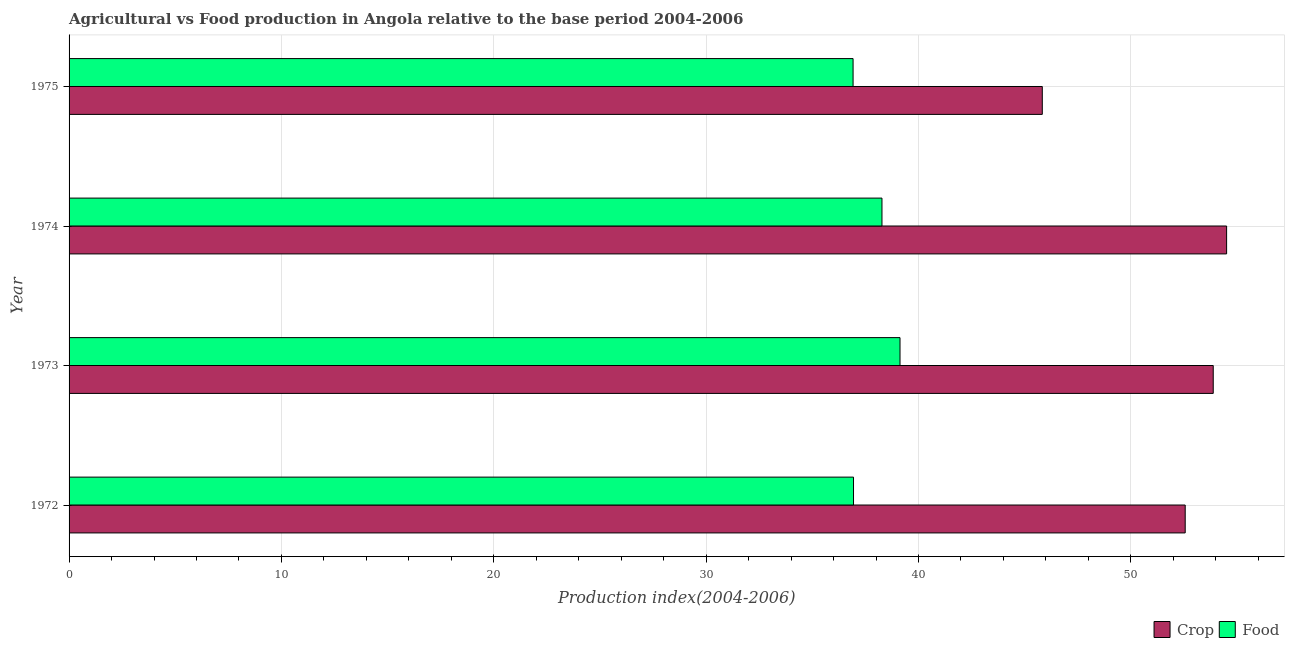What is the label of the 1st group of bars from the top?
Your answer should be very brief. 1975. What is the food production index in 1974?
Provide a short and direct response. 38.28. Across all years, what is the maximum crop production index?
Offer a terse response. 54.51. Across all years, what is the minimum food production index?
Offer a terse response. 36.92. In which year was the crop production index maximum?
Make the answer very short. 1974. In which year was the food production index minimum?
Give a very brief answer. 1975. What is the total crop production index in the graph?
Your answer should be compact. 206.78. What is the difference between the food production index in 1972 and that in 1973?
Your answer should be very brief. -2.19. What is the difference between the crop production index in 1972 and the food production index in 1974?
Your response must be concise. 14.28. What is the average food production index per year?
Keep it short and to the point. 37.82. In the year 1974, what is the difference between the crop production index and food production index?
Keep it short and to the point. 16.23. What is the ratio of the food production index in 1973 to that in 1975?
Give a very brief answer. 1.06. Is the crop production index in 1972 less than that in 1975?
Provide a short and direct response. No. What is the difference between the highest and the lowest crop production index?
Give a very brief answer. 8.68. Is the sum of the food production index in 1972 and 1974 greater than the maximum crop production index across all years?
Your answer should be compact. Yes. What does the 2nd bar from the top in 1973 represents?
Offer a very short reply. Crop. What does the 2nd bar from the bottom in 1973 represents?
Give a very brief answer. Food. How many bars are there?
Provide a short and direct response. 8. How many years are there in the graph?
Offer a very short reply. 4. What is the difference between two consecutive major ticks on the X-axis?
Provide a short and direct response. 10. Are the values on the major ticks of X-axis written in scientific E-notation?
Give a very brief answer. No. Where does the legend appear in the graph?
Your answer should be very brief. Bottom right. How many legend labels are there?
Provide a succinct answer. 2. How are the legend labels stacked?
Make the answer very short. Horizontal. What is the title of the graph?
Offer a very short reply. Agricultural vs Food production in Angola relative to the base period 2004-2006. Does "Methane" appear as one of the legend labels in the graph?
Your answer should be compact. No. What is the label or title of the X-axis?
Your answer should be compact. Production index(2004-2006). What is the Production index(2004-2006) in Crop in 1972?
Your answer should be compact. 52.56. What is the Production index(2004-2006) of Food in 1972?
Your answer should be very brief. 36.94. What is the Production index(2004-2006) of Crop in 1973?
Offer a very short reply. 53.88. What is the Production index(2004-2006) of Food in 1973?
Make the answer very short. 39.13. What is the Production index(2004-2006) in Crop in 1974?
Keep it short and to the point. 54.51. What is the Production index(2004-2006) in Food in 1974?
Ensure brevity in your answer.  38.28. What is the Production index(2004-2006) in Crop in 1975?
Provide a short and direct response. 45.83. What is the Production index(2004-2006) of Food in 1975?
Make the answer very short. 36.92. Across all years, what is the maximum Production index(2004-2006) in Crop?
Ensure brevity in your answer.  54.51. Across all years, what is the maximum Production index(2004-2006) in Food?
Your answer should be compact. 39.13. Across all years, what is the minimum Production index(2004-2006) of Crop?
Your answer should be compact. 45.83. Across all years, what is the minimum Production index(2004-2006) of Food?
Keep it short and to the point. 36.92. What is the total Production index(2004-2006) in Crop in the graph?
Your answer should be compact. 206.78. What is the total Production index(2004-2006) in Food in the graph?
Make the answer very short. 151.27. What is the difference between the Production index(2004-2006) in Crop in 1972 and that in 1973?
Keep it short and to the point. -1.32. What is the difference between the Production index(2004-2006) of Food in 1972 and that in 1973?
Your response must be concise. -2.19. What is the difference between the Production index(2004-2006) in Crop in 1972 and that in 1974?
Give a very brief answer. -1.95. What is the difference between the Production index(2004-2006) in Food in 1972 and that in 1974?
Your response must be concise. -1.34. What is the difference between the Production index(2004-2006) in Crop in 1972 and that in 1975?
Make the answer very short. 6.73. What is the difference between the Production index(2004-2006) of Crop in 1973 and that in 1974?
Your answer should be very brief. -0.63. What is the difference between the Production index(2004-2006) of Food in 1973 and that in 1974?
Make the answer very short. 0.85. What is the difference between the Production index(2004-2006) of Crop in 1973 and that in 1975?
Offer a terse response. 8.05. What is the difference between the Production index(2004-2006) of Food in 1973 and that in 1975?
Your answer should be very brief. 2.21. What is the difference between the Production index(2004-2006) in Crop in 1974 and that in 1975?
Make the answer very short. 8.68. What is the difference between the Production index(2004-2006) in Food in 1974 and that in 1975?
Give a very brief answer. 1.36. What is the difference between the Production index(2004-2006) in Crop in 1972 and the Production index(2004-2006) in Food in 1973?
Your answer should be very brief. 13.43. What is the difference between the Production index(2004-2006) of Crop in 1972 and the Production index(2004-2006) of Food in 1974?
Offer a very short reply. 14.28. What is the difference between the Production index(2004-2006) of Crop in 1972 and the Production index(2004-2006) of Food in 1975?
Your answer should be compact. 15.64. What is the difference between the Production index(2004-2006) of Crop in 1973 and the Production index(2004-2006) of Food in 1975?
Give a very brief answer. 16.96. What is the difference between the Production index(2004-2006) in Crop in 1974 and the Production index(2004-2006) in Food in 1975?
Give a very brief answer. 17.59. What is the average Production index(2004-2006) of Crop per year?
Your answer should be compact. 51.7. What is the average Production index(2004-2006) in Food per year?
Ensure brevity in your answer.  37.82. In the year 1972, what is the difference between the Production index(2004-2006) of Crop and Production index(2004-2006) of Food?
Offer a very short reply. 15.62. In the year 1973, what is the difference between the Production index(2004-2006) in Crop and Production index(2004-2006) in Food?
Ensure brevity in your answer.  14.75. In the year 1974, what is the difference between the Production index(2004-2006) in Crop and Production index(2004-2006) in Food?
Give a very brief answer. 16.23. In the year 1975, what is the difference between the Production index(2004-2006) of Crop and Production index(2004-2006) of Food?
Make the answer very short. 8.91. What is the ratio of the Production index(2004-2006) of Crop in 1972 to that in 1973?
Your answer should be very brief. 0.98. What is the ratio of the Production index(2004-2006) in Food in 1972 to that in 1973?
Keep it short and to the point. 0.94. What is the ratio of the Production index(2004-2006) of Crop in 1972 to that in 1974?
Your answer should be compact. 0.96. What is the ratio of the Production index(2004-2006) in Crop in 1972 to that in 1975?
Your answer should be compact. 1.15. What is the ratio of the Production index(2004-2006) in Crop in 1973 to that in 1974?
Give a very brief answer. 0.99. What is the ratio of the Production index(2004-2006) of Food in 1973 to that in 1974?
Ensure brevity in your answer.  1.02. What is the ratio of the Production index(2004-2006) in Crop in 1973 to that in 1975?
Offer a very short reply. 1.18. What is the ratio of the Production index(2004-2006) of Food in 1973 to that in 1975?
Your response must be concise. 1.06. What is the ratio of the Production index(2004-2006) in Crop in 1974 to that in 1975?
Give a very brief answer. 1.19. What is the ratio of the Production index(2004-2006) in Food in 1974 to that in 1975?
Your answer should be very brief. 1.04. What is the difference between the highest and the second highest Production index(2004-2006) in Crop?
Give a very brief answer. 0.63. What is the difference between the highest and the second highest Production index(2004-2006) in Food?
Provide a succinct answer. 0.85. What is the difference between the highest and the lowest Production index(2004-2006) of Crop?
Keep it short and to the point. 8.68. What is the difference between the highest and the lowest Production index(2004-2006) in Food?
Keep it short and to the point. 2.21. 